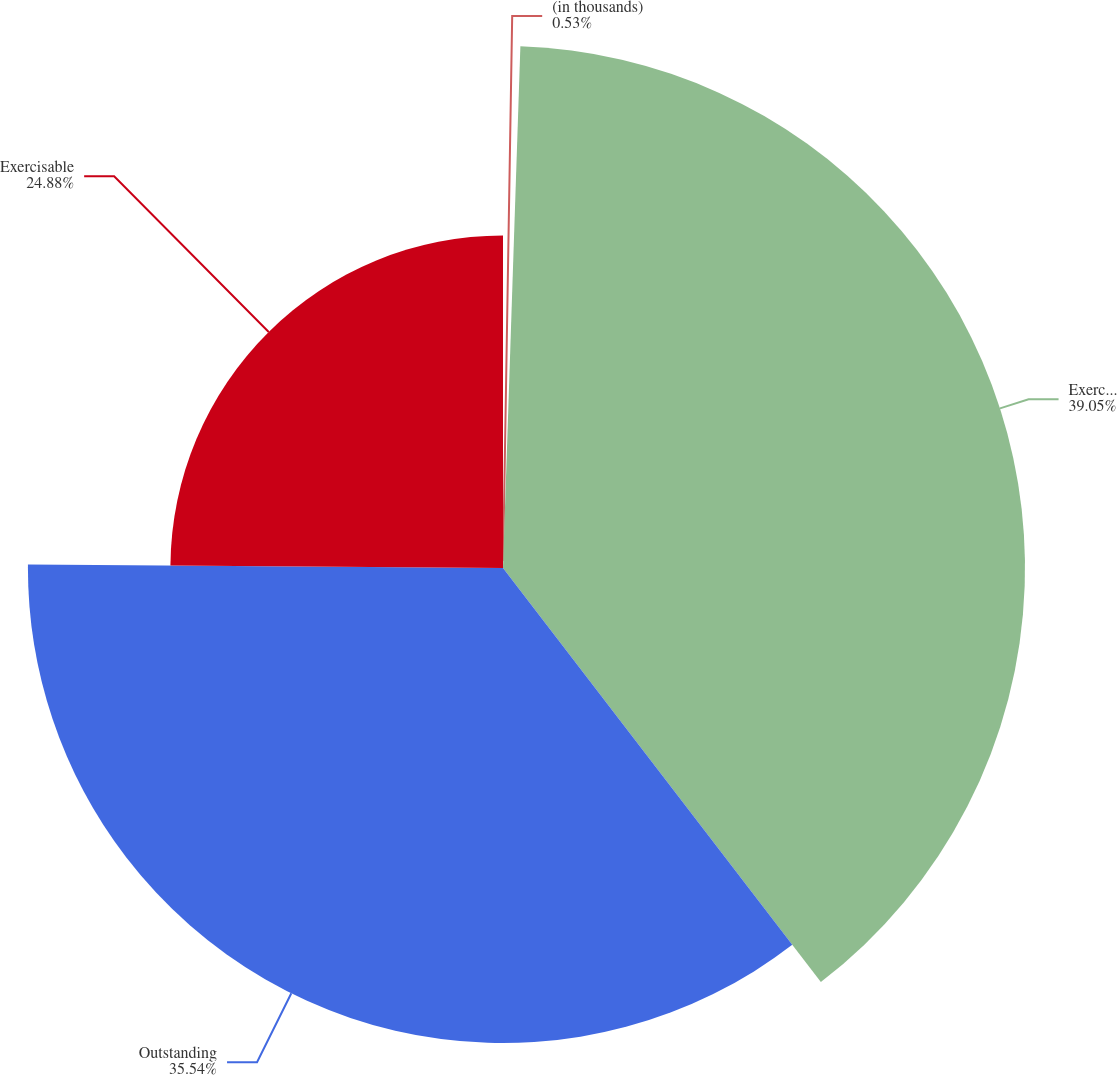Convert chart. <chart><loc_0><loc_0><loc_500><loc_500><pie_chart><fcel>(in thousands)<fcel>Exercised<fcel>Outstanding<fcel>Exercisable<nl><fcel>0.53%<fcel>39.05%<fcel>35.54%<fcel>24.88%<nl></chart> 